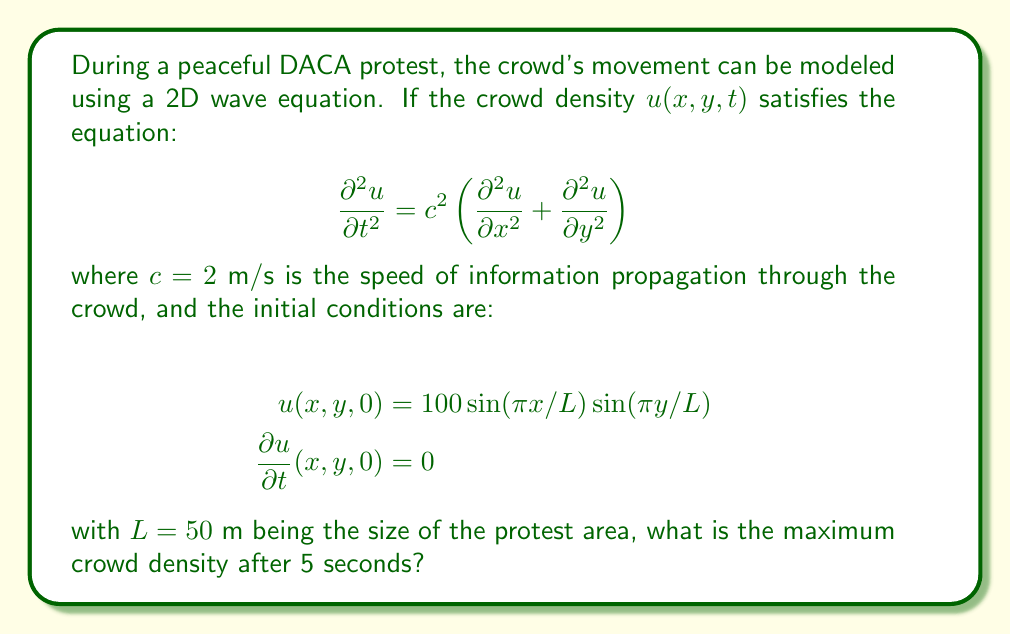Can you solve this math problem? To solve this problem, we need to follow these steps:

1) The general solution for a 2D wave equation with the given initial conditions is:

   $$u(x,y,t) = A \cos(\omega t) \sin(\pi x/L) \sin(\pi y/L)$$

   where $A$ is the amplitude and $\omega$ is the angular frequency.

2) From the initial condition $u(x,y,0) = 100 \sin(\pi x/L) \sin(\pi y/L)$, we can determine that $A = 100$.

3) To find $\omega$, we substitute the general solution into the wave equation:

   $$-A\omega^2 \cos(\omega t) \sin(\pi x/L) \sin(\pi y/L) = c^2 A \cos(\omega t) \left(-(\pi/L)^2 \sin(\pi x/L) \sin(\pi y/L) - (\pi/L)^2 \sin(\pi x/L) \sin(\pi y/L)\right)$$

4) Simplifying:

   $$\omega^2 = c^2 \left(2(\pi/L)^2\right) = 2c^2(\pi/L)^2$$

5) Solving for $\omega$:

   $$\omega = c\sqrt{2}(\pi/L) = 2\sqrt{2}(\pi/50) \approx 0.1772$$

6) Now we have the complete solution:

   $$u(x,y,t) = 100 \cos(0.1772t) \sin(\pi x/50) \sin(\pi y/50)$$

7) The maximum density will occur when $\cos(0.1772t)$ is at its maximum value of 1, which happens periodically.

8) At t = 5 seconds, $\cos(0.1772 * 5) \approx 0.4067$.

9) Therefore, the maximum crowd density at t = 5 seconds is:

   $$100 * 0.4067 * 1 * 1 = 40.67$$

   (The sine terms reach their maximum of 1 at the center of the protest area)
Answer: 40.67 people/m² 